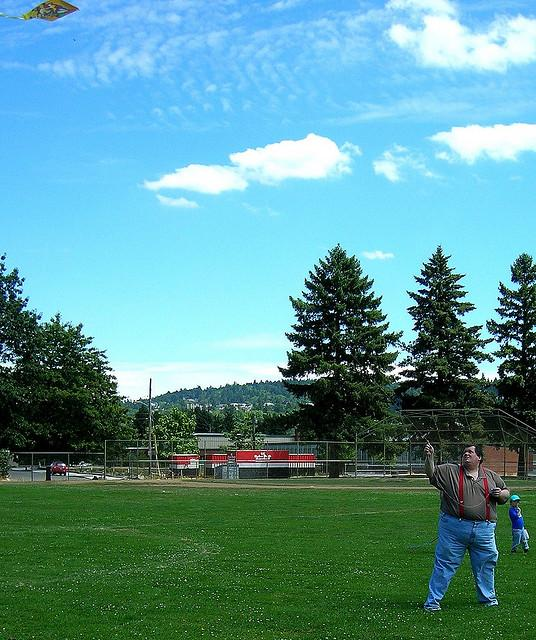The man in brown Controls what? kite 